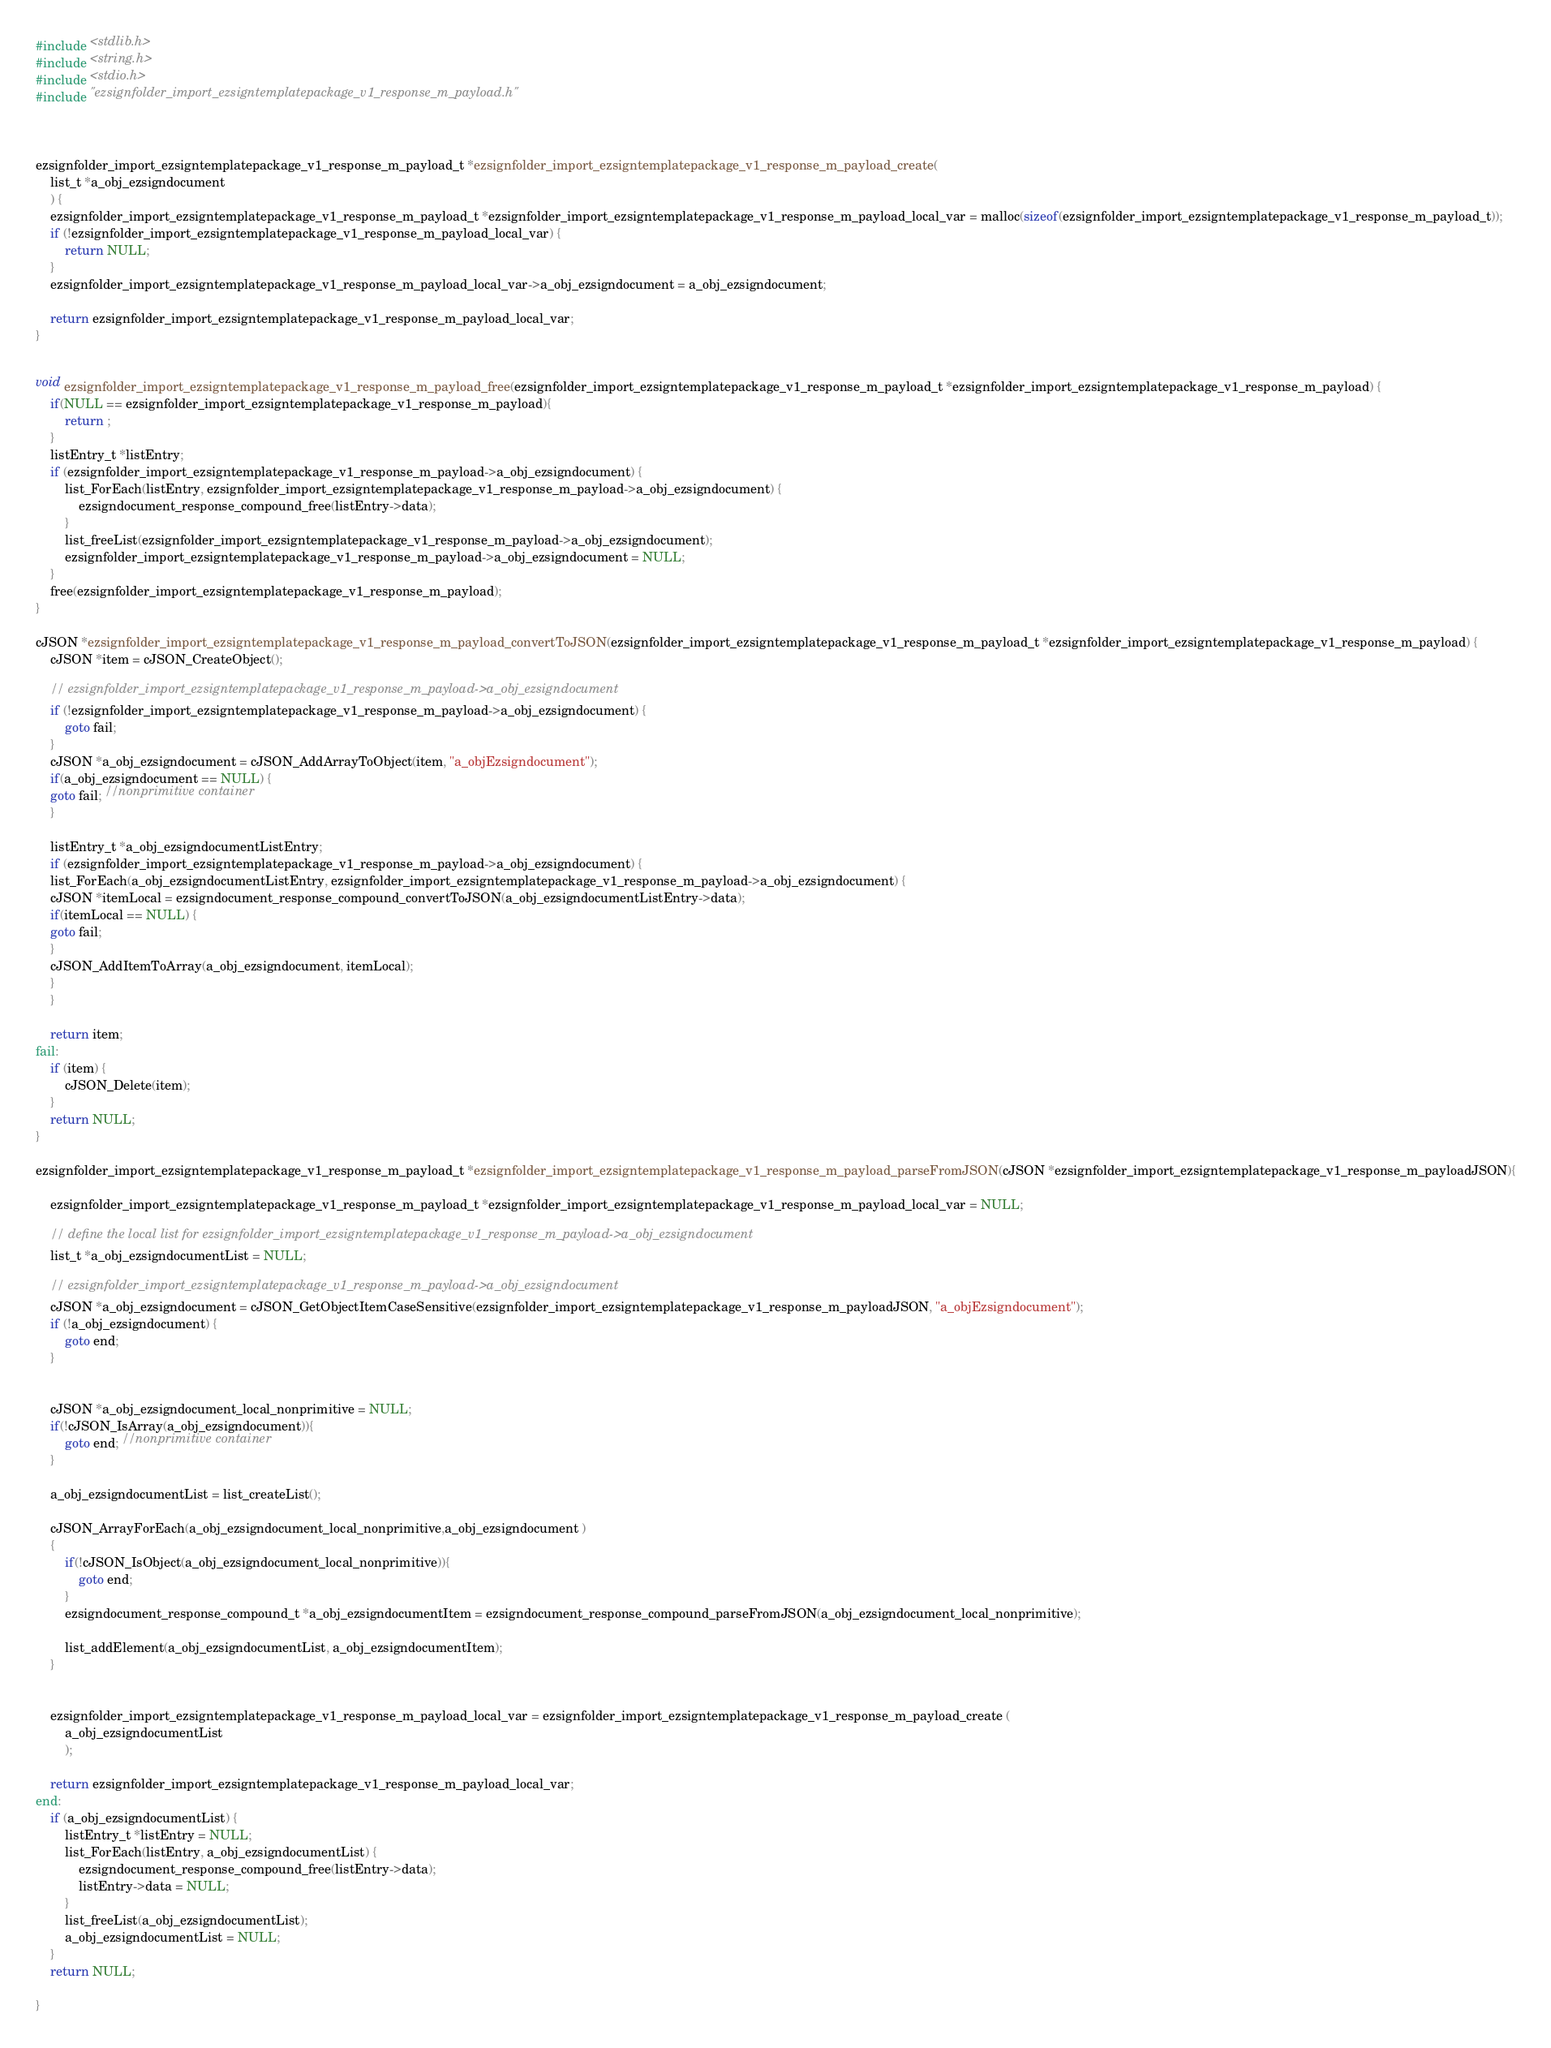<code> <loc_0><loc_0><loc_500><loc_500><_C_>#include <stdlib.h>
#include <string.h>
#include <stdio.h>
#include "ezsignfolder_import_ezsigntemplatepackage_v1_response_m_payload.h"



ezsignfolder_import_ezsigntemplatepackage_v1_response_m_payload_t *ezsignfolder_import_ezsigntemplatepackage_v1_response_m_payload_create(
    list_t *a_obj_ezsigndocument
    ) {
    ezsignfolder_import_ezsigntemplatepackage_v1_response_m_payload_t *ezsignfolder_import_ezsigntemplatepackage_v1_response_m_payload_local_var = malloc(sizeof(ezsignfolder_import_ezsigntemplatepackage_v1_response_m_payload_t));
    if (!ezsignfolder_import_ezsigntemplatepackage_v1_response_m_payload_local_var) {
        return NULL;
    }
    ezsignfolder_import_ezsigntemplatepackage_v1_response_m_payload_local_var->a_obj_ezsigndocument = a_obj_ezsigndocument;

    return ezsignfolder_import_ezsigntemplatepackage_v1_response_m_payload_local_var;
}


void ezsignfolder_import_ezsigntemplatepackage_v1_response_m_payload_free(ezsignfolder_import_ezsigntemplatepackage_v1_response_m_payload_t *ezsignfolder_import_ezsigntemplatepackage_v1_response_m_payload) {
    if(NULL == ezsignfolder_import_ezsigntemplatepackage_v1_response_m_payload){
        return ;
    }
    listEntry_t *listEntry;
    if (ezsignfolder_import_ezsigntemplatepackage_v1_response_m_payload->a_obj_ezsigndocument) {
        list_ForEach(listEntry, ezsignfolder_import_ezsigntemplatepackage_v1_response_m_payload->a_obj_ezsigndocument) {
            ezsigndocument_response_compound_free(listEntry->data);
        }
        list_freeList(ezsignfolder_import_ezsigntemplatepackage_v1_response_m_payload->a_obj_ezsigndocument);
        ezsignfolder_import_ezsigntemplatepackage_v1_response_m_payload->a_obj_ezsigndocument = NULL;
    }
    free(ezsignfolder_import_ezsigntemplatepackage_v1_response_m_payload);
}

cJSON *ezsignfolder_import_ezsigntemplatepackage_v1_response_m_payload_convertToJSON(ezsignfolder_import_ezsigntemplatepackage_v1_response_m_payload_t *ezsignfolder_import_ezsigntemplatepackage_v1_response_m_payload) {
    cJSON *item = cJSON_CreateObject();

    // ezsignfolder_import_ezsigntemplatepackage_v1_response_m_payload->a_obj_ezsigndocument
    if (!ezsignfolder_import_ezsigntemplatepackage_v1_response_m_payload->a_obj_ezsigndocument) {
        goto fail;
    }
    cJSON *a_obj_ezsigndocument = cJSON_AddArrayToObject(item, "a_objEzsigndocument");
    if(a_obj_ezsigndocument == NULL) {
    goto fail; //nonprimitive container
    }

    listEntry_t *a_obj_ezsigndocumentListEntry;
    if (ezsignfolder_import_ezsigntemplatepackage_v1_response_m_payload->a_obj_ezsigndocument) {
    list_ForEach(a_obj_ezsigndocumentListEntry, ezsignfolder_import_ezsigntemplatepackage_v1_response_m_payload->a_obj_ezsigndocument) {
    cJSON *itemLocal = ezsigndocument_response_compound_convertToJSON(a_obj_ezsigndocumentListEntry->data);
    if(itemLocal == NULL) {
    goto fail;
    }
    cJSON_AddItemToArray(a_obj_ezsigndocument, itemLocal);
    }
    }

    return item;
fail:
    if (item) {
        cJSON_Delete(item);
    }
    return NULL;
}

ezsignfolder_import_ezsigntemplatepackage_v1_response_m_payload_t *ezsignfolder_import_ezsigntemplatepackage_v1_response_m_payload_parseFromJSON(cJSON *ezsignfolder_import_ezsigntemplatepackage_v1_response_m_payloadJSON){

    ezsignfolder_import_ezsigntemplatepackage_v1_response_m_payload_t *ezsignfolder_import_ezsigntemplatepackage_v1_response_m_payload_local_var = NULL;

    // define the local list for ezsignfolder_import_ezsigntemplatepackage_v1_response_m_payload->a_obj_ezsigndocument
    list_t *a_obj_ezsigndocumentList = NULL;

    // ezsignfolder_import_ezsigntemplatepackage_v1_response_m_payload->a_obj_ezsigndocument
    cJSON *a_obj_ezsigndocument = cJSON_GetObjectItemCaseSensitive(ezsignfolder_import_ezsigntemplatepackage_v1_response_m_payloadJSON, "a_objEzsigndocument");
    if (!a_obj_ezsigndocument) {
        goto end;
    }

    
    cJSON *a_obj_ezsigndocument_local_nonprimitive = NULL;
    if(!cJSON_IsArray(a_obj_ezsigndocument)){
        goto end; //nonprimitive container
    }

    a_obj_ezsigndocumentList = list_createList();

    cJSON_ArrayForEach(a_obj_ezsigndocument_local_nonprimitive,a_obj_ezsigndocument )
    {
        if(!cJSON_IsObject(a_obj_ezsigndocument_local_nonprimitive)){
            goto end;
        }
        ezsigndocument_response_compound_t *a_obj_ezsigndocumentItem = ezsigndocument_response_compound_parseFromJSON(a_obj_ezsigndocument_local_nonprimitive);

        list_addElement(a_obj_ezsigndocumentList, a_obj_ezsigndocumentItem);
    }


    ezsignfolder_import_ezsigntemplatepackage_v1_response_m_payload_local_var = ezsignfolder_import_ezsigntemplatepackage_v1_response_m_payload_create (
        a_obj_ezsigndocumentList
        );

    return ezsignfolder_import_ezsigntemplatepackage_v1_response_m_payload_local_var;
end:
    if (a_obj_ezsigndocumentList) {
        listEntry_t *listEntry = NULL;
        list_ForEach(listEntry, a_obj_ezsigndocumentList) {
            ezsigndocument_response_compound_free(listEntry->data);
            listEntry->data = NULL;
        }
        list_freeList(a_obj_ezsigndocumentList);
        a_obj_ezsigndocumentList = NULL;
    }
    return NULL;

}
</code> 